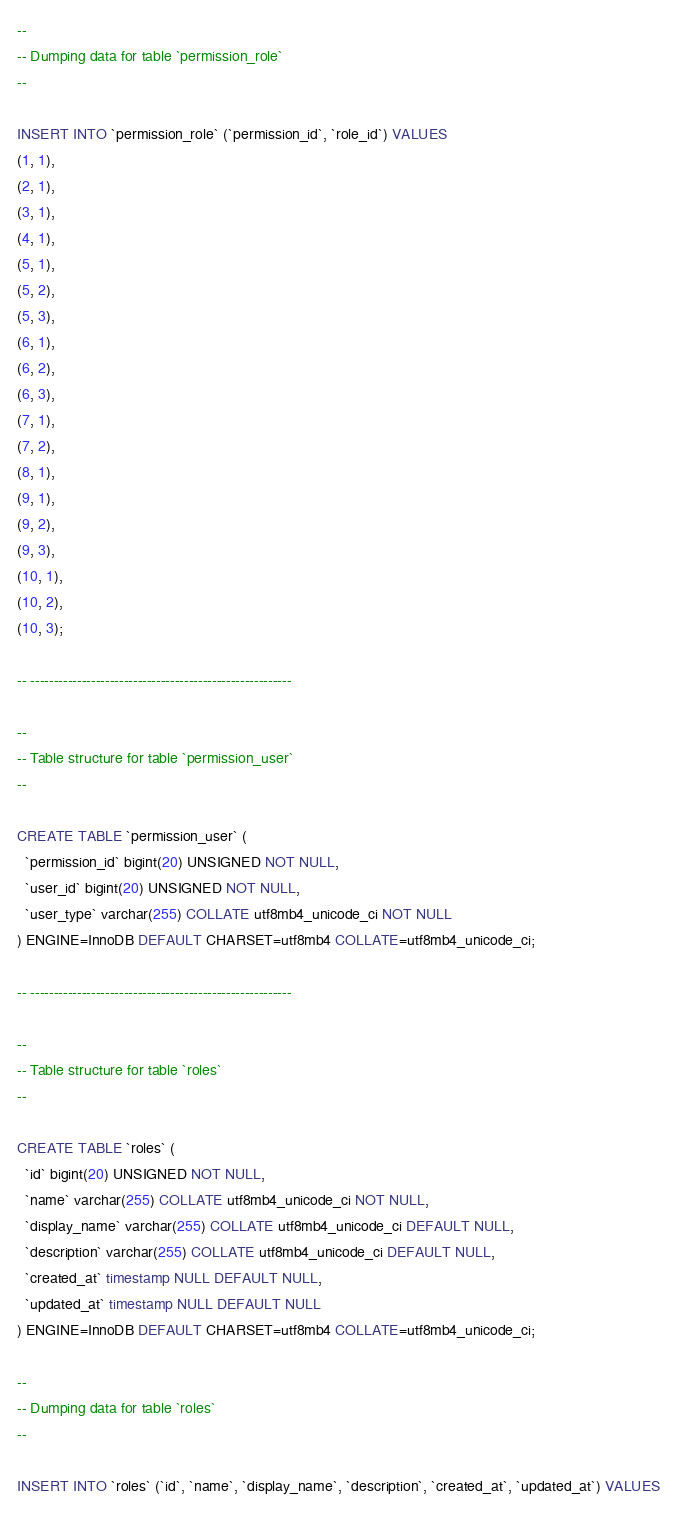<code> <loc_0><loc_0><loc_500><loc_500><_SQL_>--
-- Dumping data for table `permission_role`
--

INSERT INTO `permission_role` (`permission_id`, `role_id`) VALUES
(1, 1),
(2, 1),
(3, 1),
(4, 1),
(5, 1),
(5, 2),
(5, 3),
(6, 1),
(6, 2),
(6, 3),
(7, 1),
(7, 2),
(8, 1),
(9, 1),
(9, 2),
(9, 3),
(10, 1),
(10, 2),
(10, 3);

-- --------------------------------------------------------

--
-- Table structure for table `permission_user`
--

CREATE TABLE `permission_user` (
  `permission_id` bigint(20) UNSIGNED NOT NULL,
  `user_id` bigint(20) UNSIGNED NOT NULL,
  `user_type` varchar(255) COLLATE utf8mb4_unicode_ci NOT NULL
) ENGINE=InnoDB DEFAULT CHARSET=utf8mb4 COLLATE=utf8mb4_unicode_ci;

-- --------------------------------------------------------

--
-- Table structure for table `roles`
--

CREATE TABLE `roles` (
  `id` bigint(20) UNSIGNED NOT NULL,
  `name` varchar(255) COLLATE utf8mb4_unicode_ci NOT NULL,
  `display_name` varchar(255) COLLATE utf8mb4_unicode_ci DEFAULT NULL,
  `description` varchar(255) COLLATE utf8mb4_unicode_ci DEFAULT NULL,
  `created_at` timestamp NULL DEFAULT NULL,
  `updated_at` timestamp NULL DEFAULT NULL
) ENGINE=InnoDB DEFAULT CHARSET=utf8mb4 COLLATE=utf8mb4_unicode_ci;

--
-- Dumping data for table `roles`
--

INSERT INTO `roles` (`id`, `name`, `display_name`, `description`, `created_at`, `updated_at`) VALUES</code> 